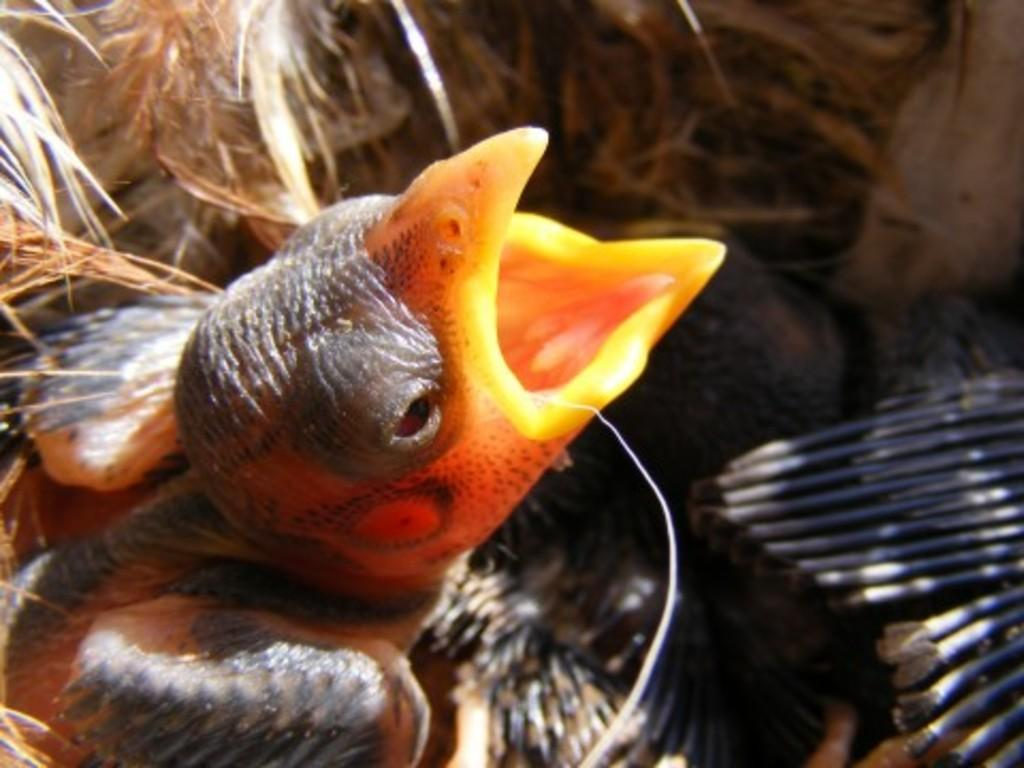What type of animal can be seen in the image? There is a bird in the image. What color are the objects on the right side of the image? The objects on the right side of the image are black. What type of vegetation is visible at the top of the image? There is dry grass visible at the top of the image. What type of class is the bird attending in the image? There is no indication in the image that the bird is attending a class. How does the bird rest in the image? The image does not show the bird resting; it is perched on a branch. 